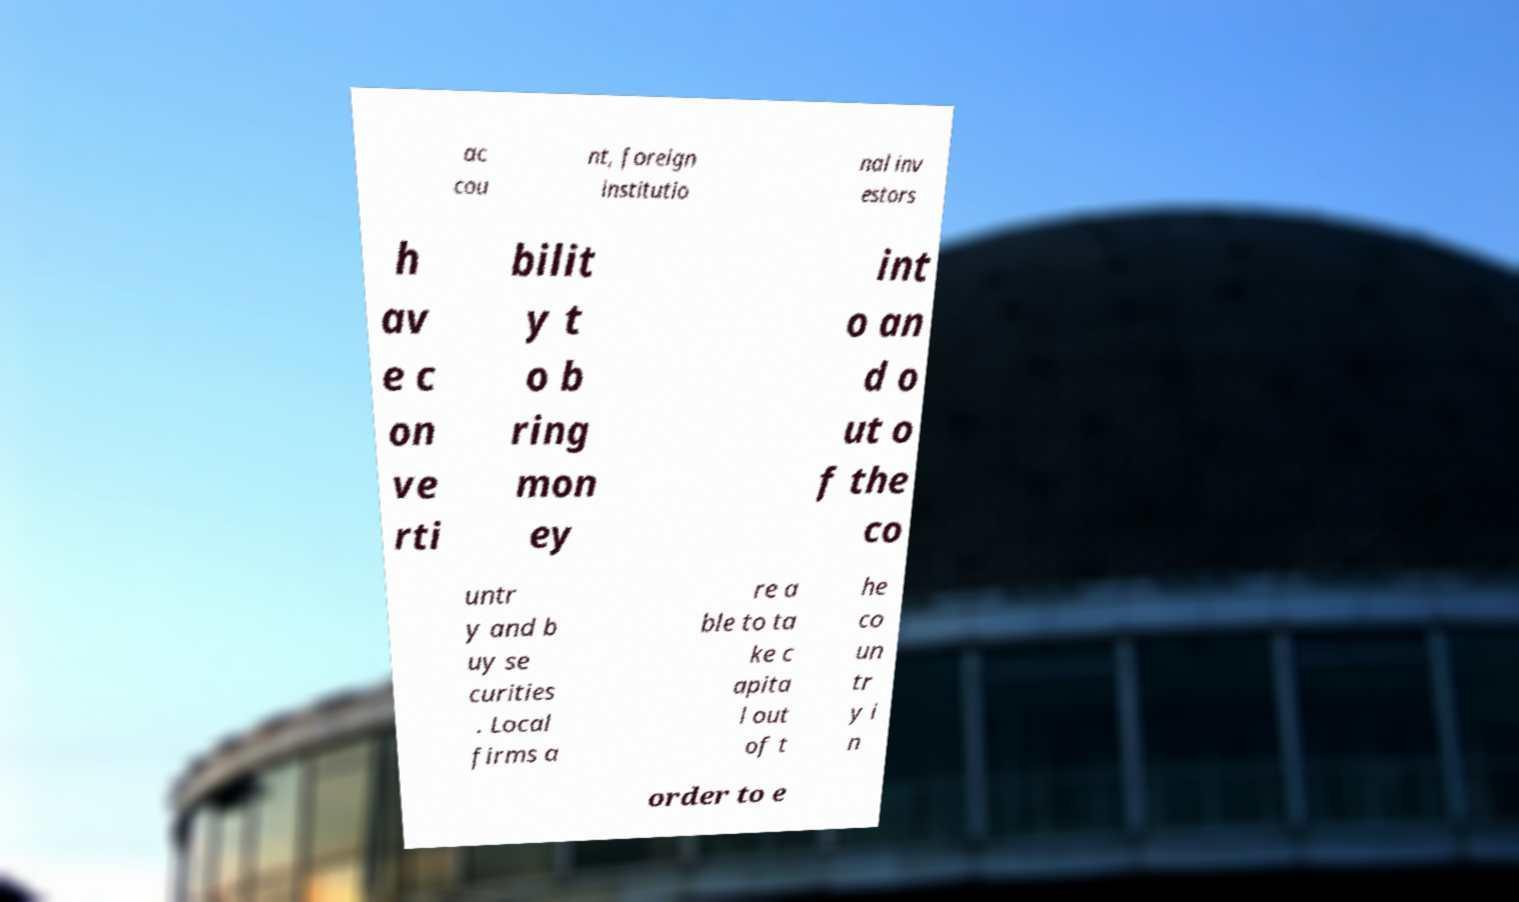Could you assist in decoding the text presented in this image and type it out clearly? ac cou nt, foreign institutio nal inv estors h av e c on ve rti bilit y t o b ring mon ey int o an d o ut o f the co untr y and b uy se curities . Local firms a re a ble to ta ke c apita l out of t he co un tr y i n order to e 